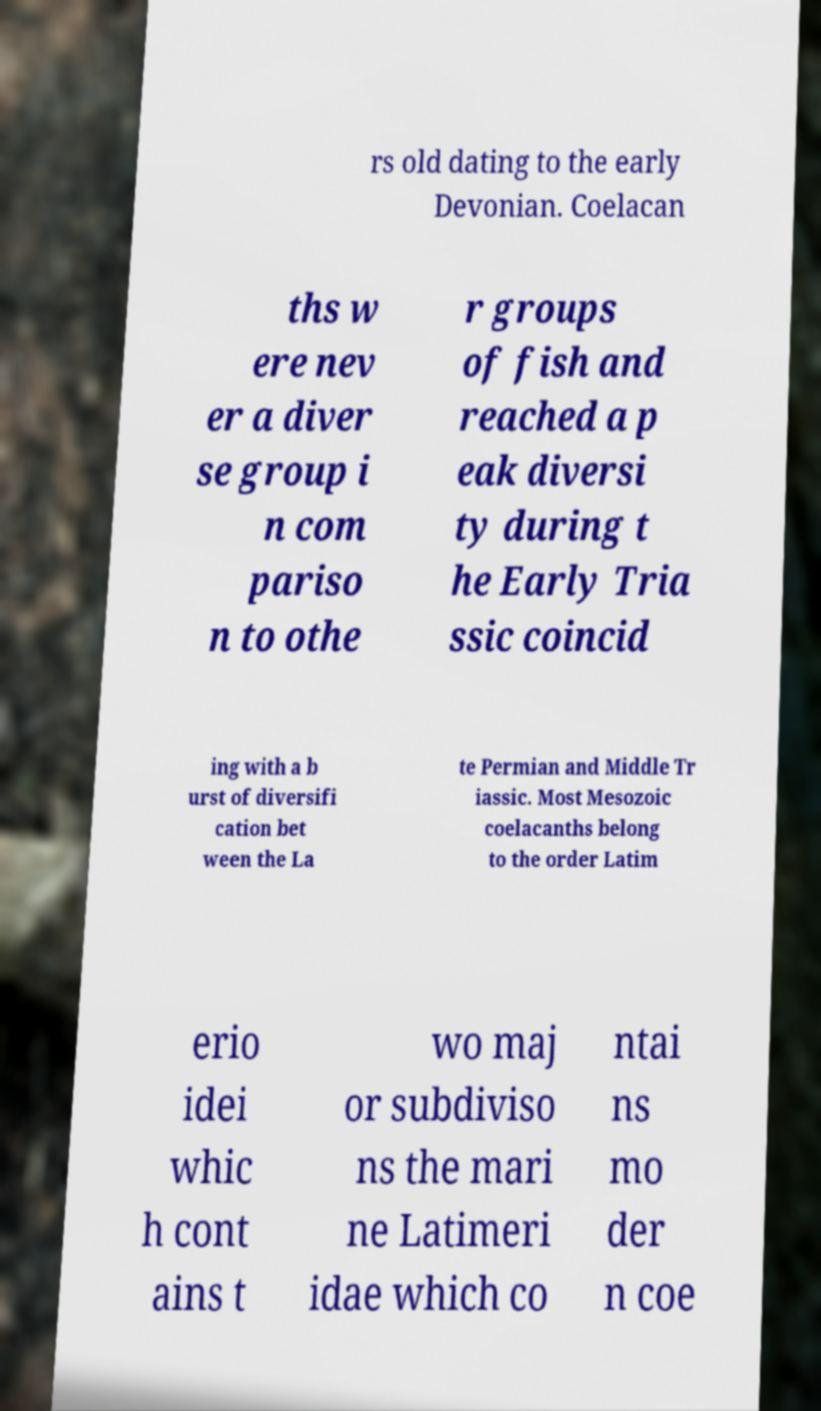I need the written content from this picture converted into text. Can you do that? rs old dating to the early Devonian. Coelacan ths w ere nev er a diver se group i n com pariso n to othe r groups of fish and reached a p eak diversi ty during t he Early Tria ssic coincid ing with a b urst of diversifi cation bet ween the La te Permian and Middle Tr iassic. Most Mesozoic coelacanths belong to the order Latim erio idei whic h cont ains t wo maj or subdiviso ns the mari ne Latimeri idae which co ntai ns mo der n coe 